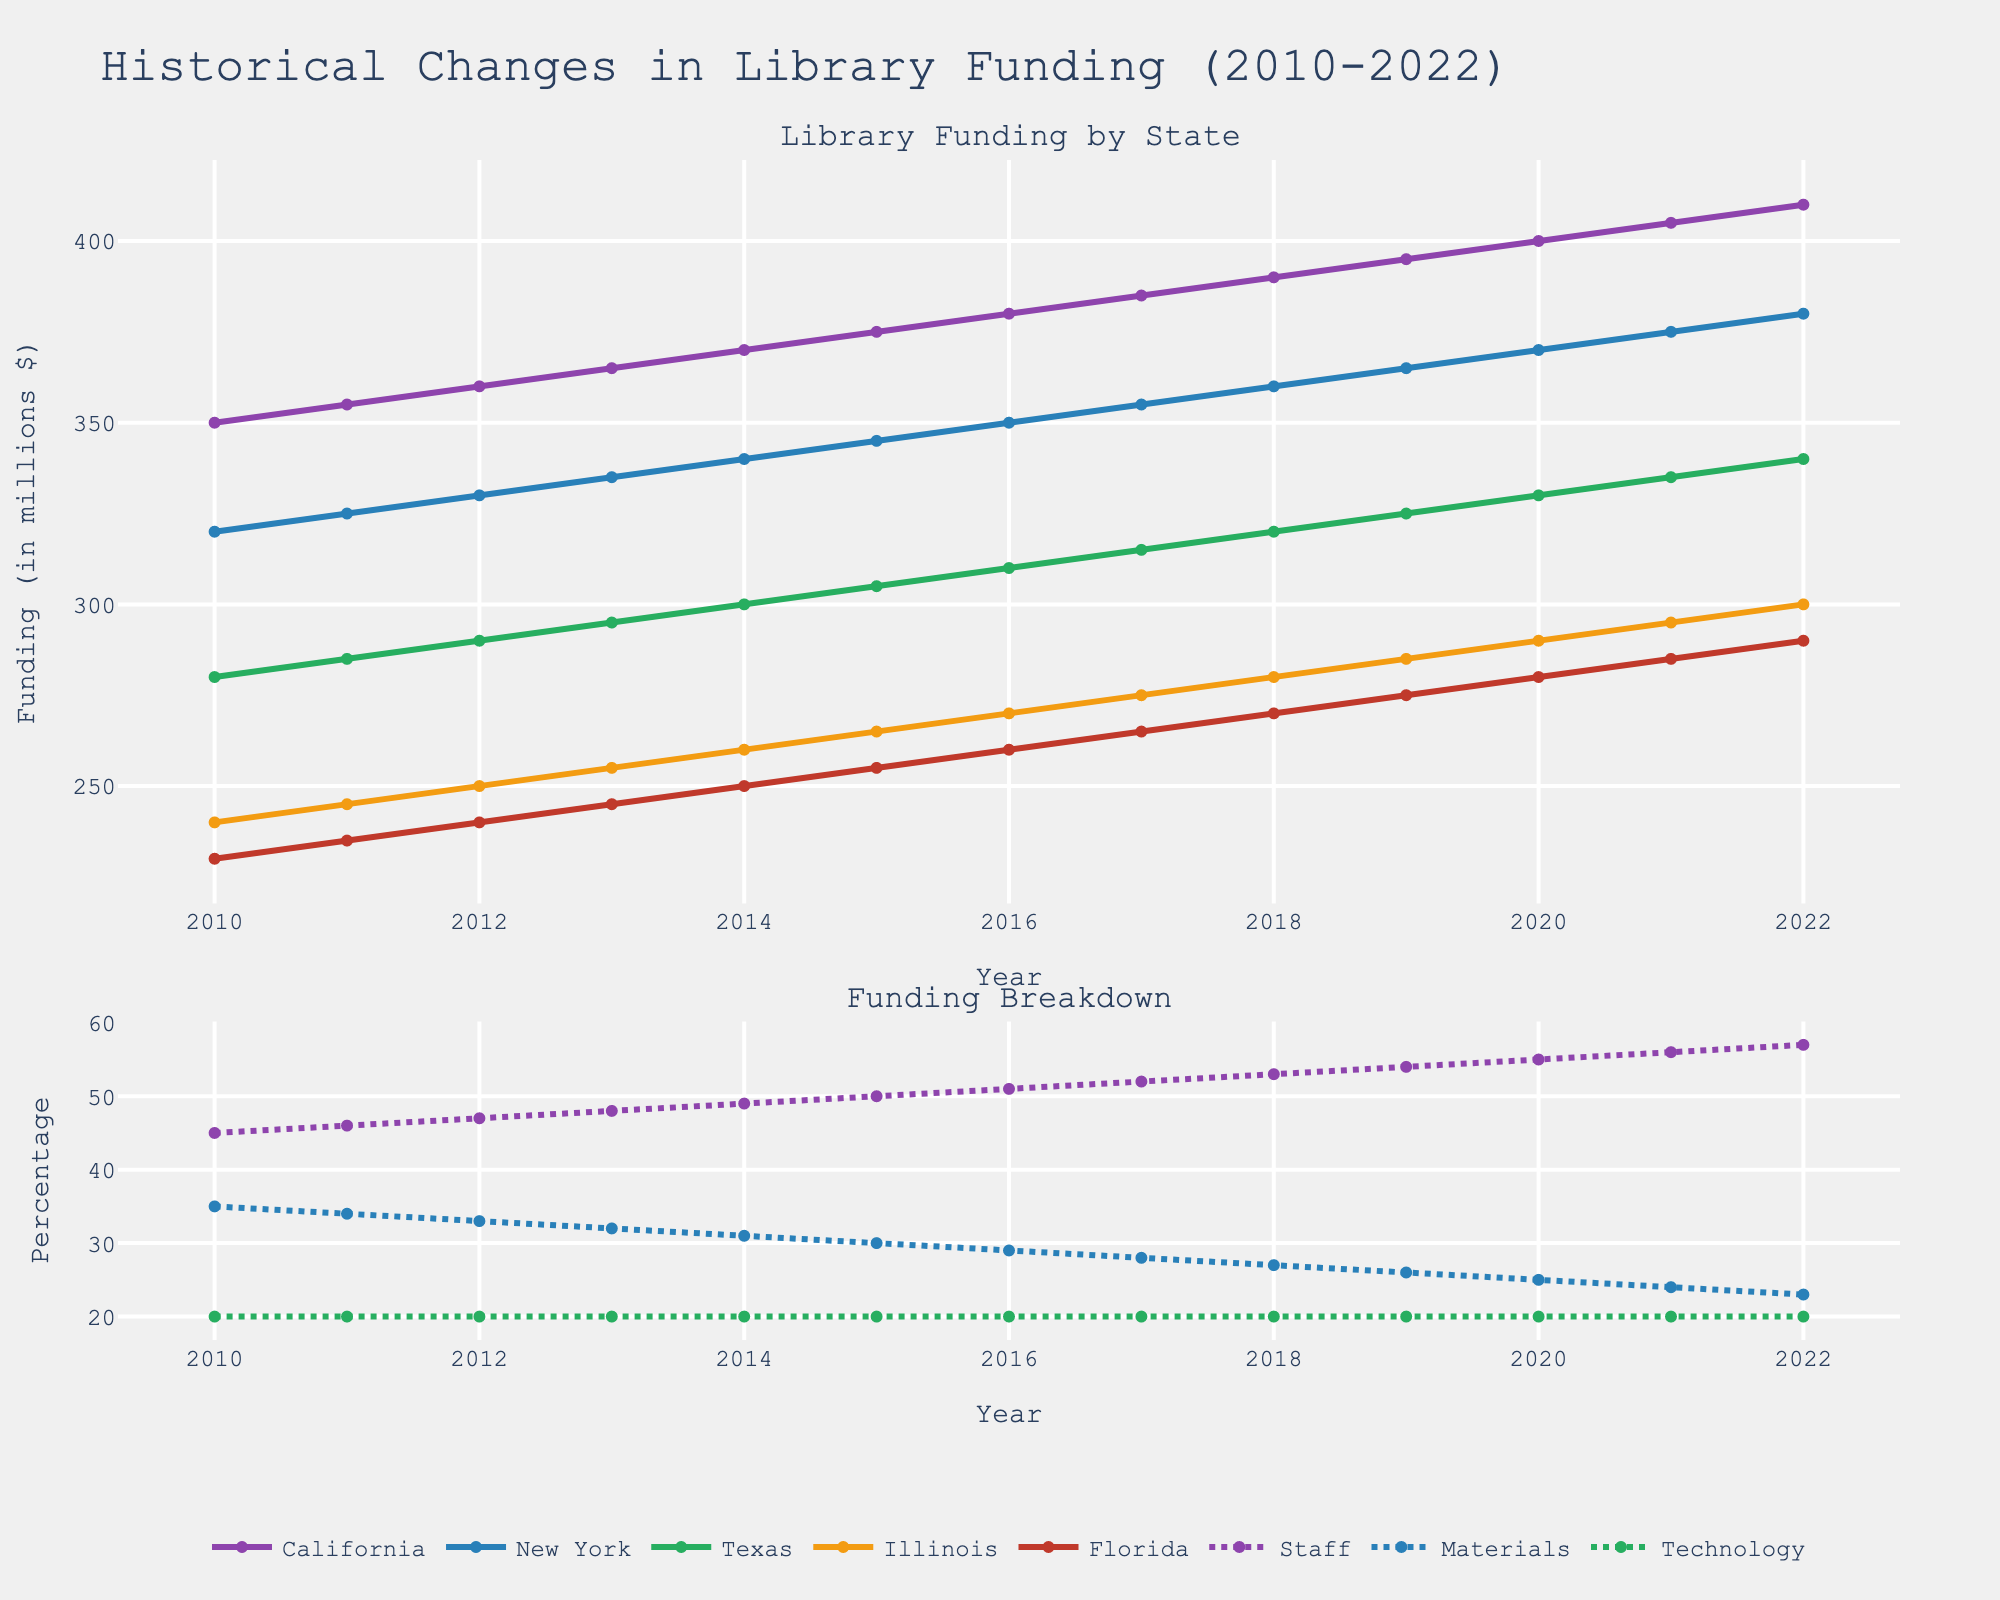What is the total funding change for California from 2010 to 2022? The funding in California in 2010 is 350 million dollars, and it increases to 410 million dollars by 2022. The difference is calculated as 410 - 350 = 60 million dollars.
Answer: 60 million dollars Between New York and Texas, which state had a higher funding in 2015? From the line chart, in 2015, New York's funding is 345 million dollars, while Texas's funding is 305 million dollars. Since 345 > 305, New York had higher funding.
Answer: New York In 2020, did the technology funding percentage change compared to 2010? Technology funding is represented by the dotted line in the second subplot. The percentage remains at 20% throughout these years from 2010 to 2020, indicating no change.
Answer: No change What is the difference in funding for Staff between 2012 and 2022? Staff funding in 2012 is 47%, and in 2022 it is 57%. The difference is calculated as 57 - 47 = 10 percentage points.
Answer: 10 percentage points Which state had the lowest funding in 2019? By examining the line chart for the year 2019, Florida shows the lowest funding at 275 million dollars compared to the other states.
Answer: Florida Is the trend for Illinois' funding increasing, decreasing, or stable from 2010 to 2022? Observing the line for Illinois, it shows a continuous upward trend from 240 million dollars in 2010 to 300 million dollars in 2022.
Answer: Increasing What is the average funding for New York between 2010 and 2015? Funding for New York between 2010 and 2015: 320, 325, 330, 335, 340, 345. Sum these values: 320 + 325 + 330 + 335 + 340 + 345 = 1995. The average is 1995/6 = 332.5 million dollars.
Answer: 332.5 million dollars During which year do Staff and Materials funding intersect? Examining the dotted lines in the second subplot, Staff and Materials funding do not intersect in any given year; Staff funding remains consistently higher than Materials funding.
Answer: They don't intersect Was there any year when Florida's funding was equal to California’s funding for any category? Observing the lines for Florida and California, there is no point where the funding amounts for any category exactly match in any given year.
Answer: No Which funding category showed no change over the entire period? The dotted line for Technology in the second subplot remains constant at 20% from 2010 through 2022, indicating no change.
Answer: Technology 